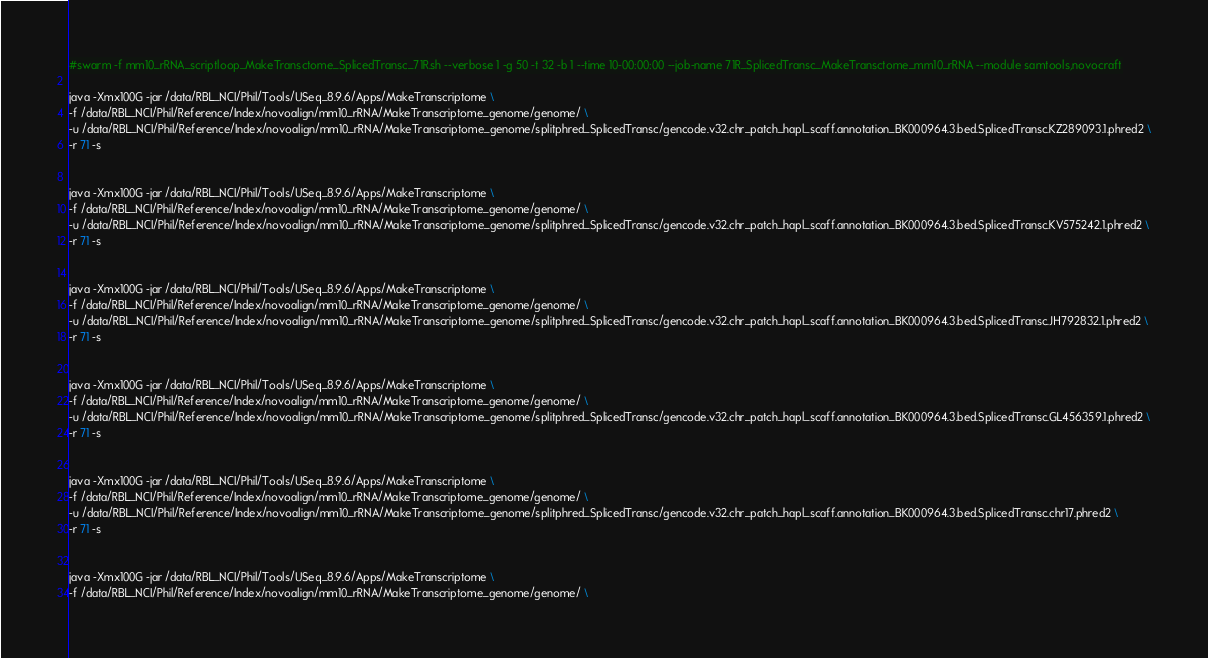Convert code to text. <code><loc_0><loc_0><loc_500><loc_500><_Bash_>#swarm -f mm10_rRNA_scriptloop_MakeTransctome_SplicedTransc_71R.sh --verbose 1 -g 50 -t 32 -b 1 --time 10-00:00:00 --job-name 71R_SplicedTransc_MakeTransctome_mm10_rRNA --module samtools,novocraft

java -Xmx100G -jar /data/RBL_NCI/Phil/Tools/USeq_8.9.6/Apps/MakeTranscriptome \
-f /data/RBL_NCI/Phil/Reference/Index/novoalign/mm10_rRNA/MakeTranscriptome_genome/genome/ \
-u /data/RBL_NCI/Phil/Reference/Index/novoalign/mm10_rRNA/MakeTranscriptome_genome/splitphred_SplicedTransc/gencode.v32.chr_patch_hapl_scaff.annotation_BK000964.3.bed.SplicedTransc.KZ289093.1.phred2 \
-r 71 -s 


java -Xmx100G -jar /data/RBL_NCI/Phil/Tools/USeq_8.9.6/Apps/MakeTranscriptome \
-f /data/RBL_NCI/Phil/Reference/Index/novoalign/mm10_rRNA/MakeTranscriptome_genome/genome/ \
-u /data/RBL_NCI/Phil/Reference/Index/novoalign/mm10_rRNA/MakeTranscriptome_genome/splitphred_SplicedTransc/gencode.v32.chr_patch_hapl_scaff.annotation_BK000964.3.bed.SplicedTransc.KV575242.1.phred2 \
-r 71 -s 


java -Xmx100G -jar /data/RBL_NCI/Phil/Tools/USeq_8.9.6/Apps/MakeTranscriptome \
-f /data/RBL_NCI/Phil/Reference/Index/novoalign/mm10_rRNA/MakeTranscriptome_genome/genome/ \
-u /data/RBL_NCI/Phil/Reference/Index/novoalign/mm10_rRNA/MakeTranscriptome_genome/splitphred_SplicedTransc/gencode.v32.chr_patch_hapl_scaff.annotation_BK000964.3.bed.SplicedTransc.JH792832.1.phred2 \
-r 71 -s 


java -Xmx100G -jar /data/RBL_NCI/Phil/Tools/USeq_8.9.6/Apps/MakeTranscriptome \
-f /data/RBL_NCI/Phil/Reference/Index/novoalign/mm10_rRNA/MakeTranscriptome_genome/genome/ \
-u /data/RBL_NCI/Phil/Reference/Index/novoalign/mm10_rRNA/MakeTranscriptome_genome/splitphred_SplicedTransc/gencode.v32.chr_patch_hapl_scaff.annotation_BK000964.3.bed.SplicedTransc.GL456359.1.phred2 \
-r 71 -s 


java -Xmx100G -jar /data/RBL_NCI/Phil/Tools/USeq_8.9.6/Apps/MakeTranscriptome \
-f /data/RBL_NCI/Phil/Reference/Index/novoalign/mm10_rRNA/MakeTranscriptome_genome/genome/ \
-u /data/RBL_NCI/Phil/Reference/Index/novoalign/mm10_rRNA/MakeTranscriptome_genome/splitphred_SplicedTransc/gencode.v32.chr_patch_hapl_scaff.annotation_BK000964.3.bed.SplicedTransc.chr17.phred2 \
-r 71 -s 


java -Xmx100G -jar /data/RBL_NCI/Phil/Tools/USeq_8.9.6/Apps/MakeTranscriptome \
-f /data/RBL_NCI/Phil/Reference/Index/novoalign/mm10_rRNA/MakeTranscriptome_genome/genome/ \</code> 